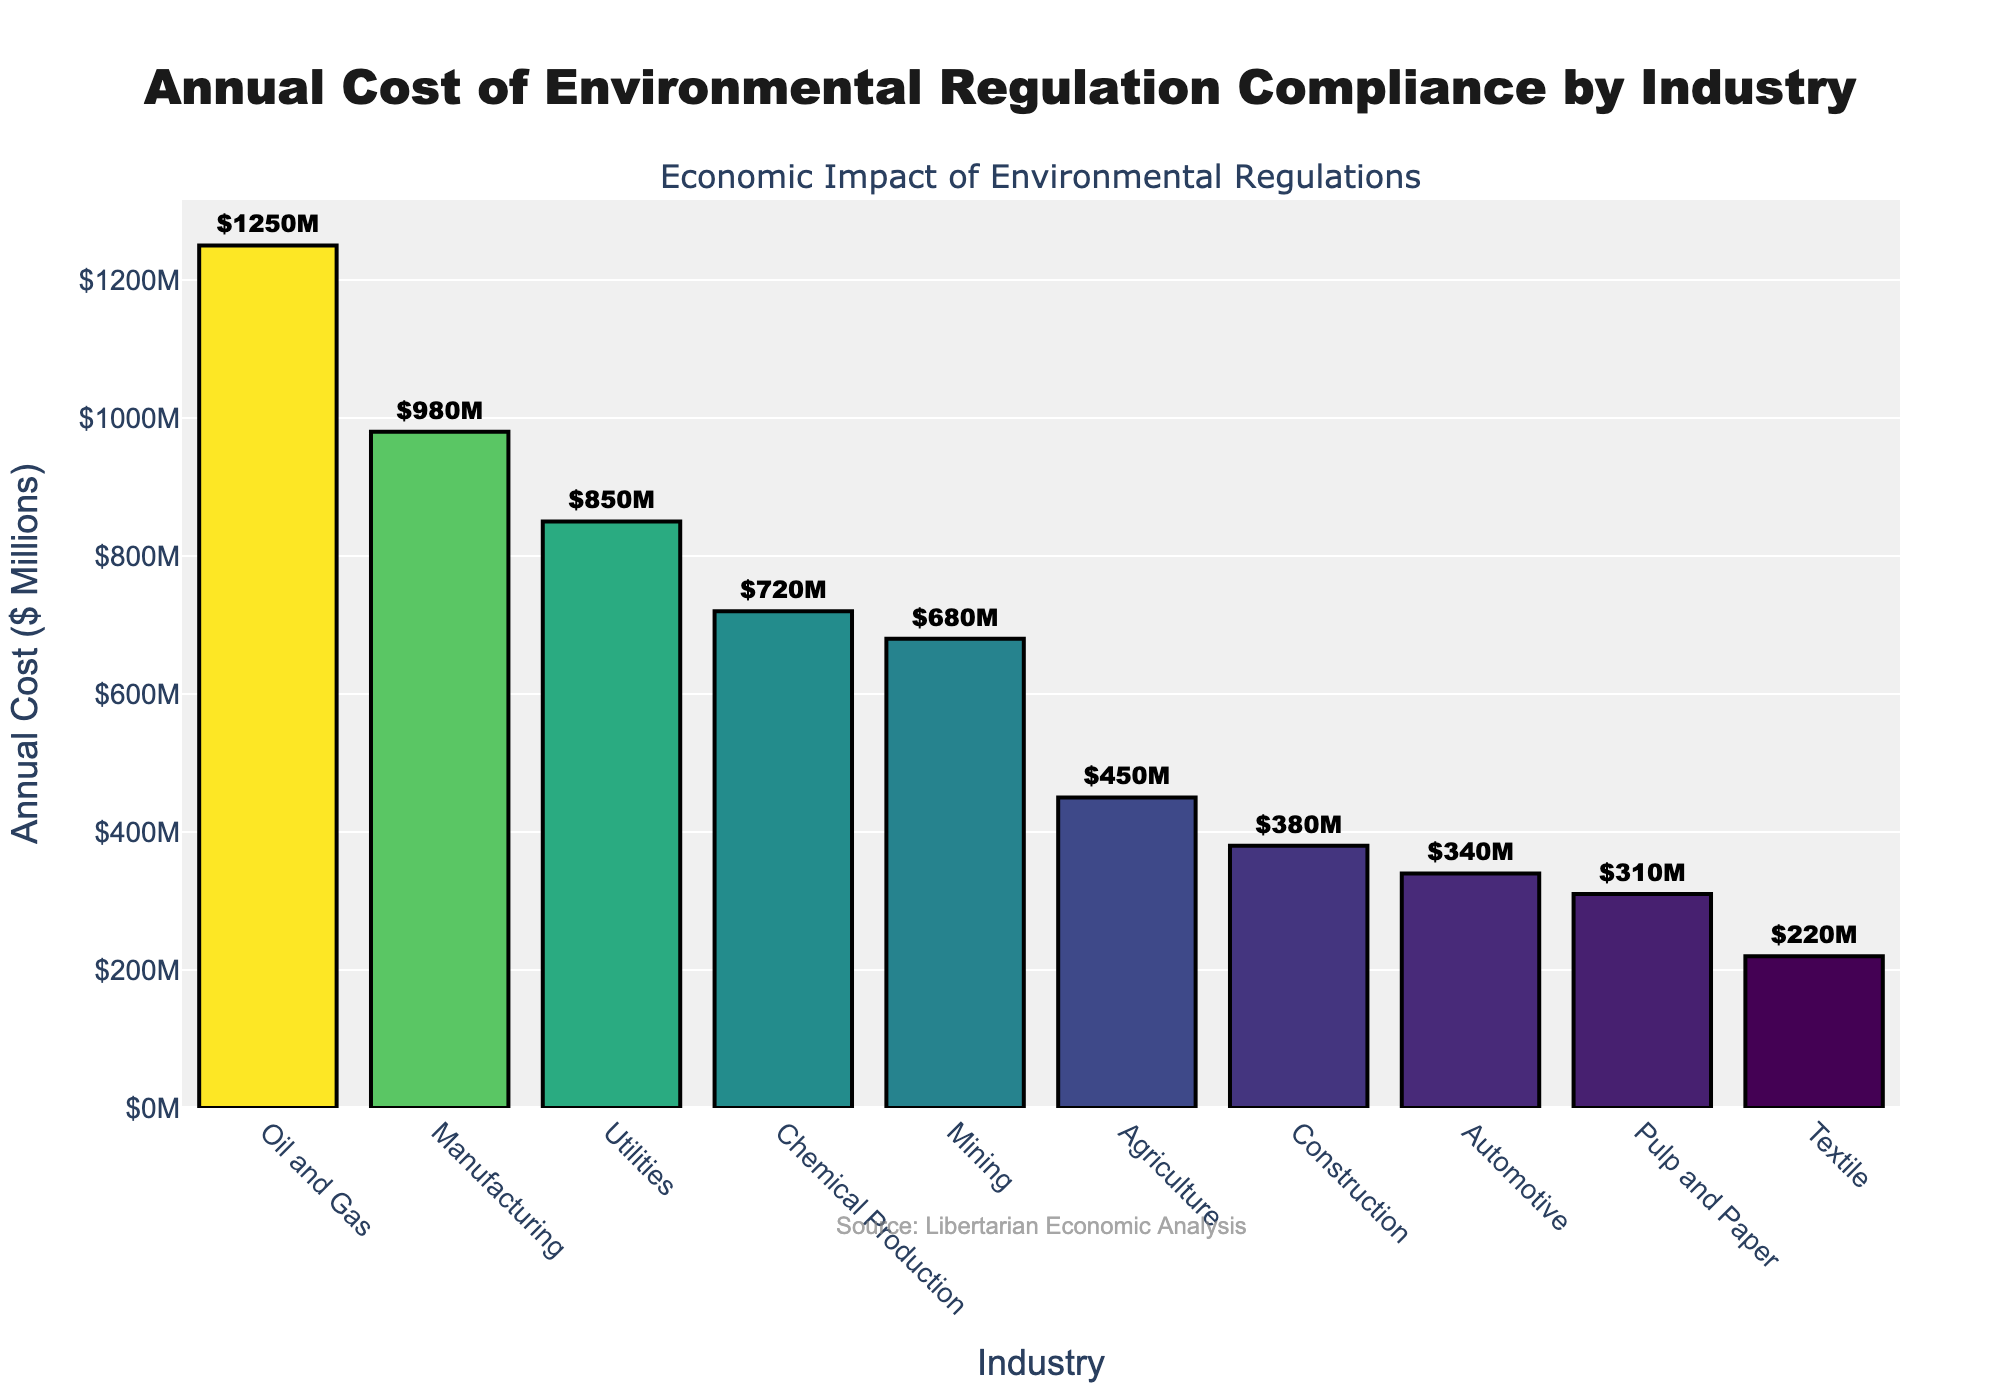What's the total annual cost of compliance across all industries? Sum up all the annual costs of compliance: 1250 + 980 + 850 + 720 + 680 + 450 + 380 + 340 + 310 + 220 = 6180 million dollars
Answer: 6180 million dollars Which industry has the highest annual cost of compliance? Look at the industry with the tallest bar in the chart, which is labeled as Oil and Gas, and its cost is $1250 million
Answer: Oil and Gas How much more does the Oil and Gas industry spend on compliance compared to the Textile industry? Subtract the annual cost of compliance of Textile ($220 million) from that of Oil and Gas ($1250 million): 1250 - 220 = 1030 million dollars
Answer: 1030 million dollars What is the average annual cost of compliance among the top three industries? Sum the costs of the top three industries: 1250 (Oil and Gas) + 980 (Manufacturing) + 850 (Utilities) = 3080, then divide by 3: 3080 ÷ 3 = 1026.67 million dollars
Answer: 1026.67 million dollars What percentage of the total cost is attributed to the Mining industry? Divide the Mining industry's cost by the total cost and multiply by 100: (680 / 6180) * 100 ≈ 11%
Answer: 11% What is the range of the annual costs of compliance across all industries? Subtract the lowest annual cost (Textile, $220 million) from the highest (Oil and Gas, $1250 million): 1250 - 220 = 1030 million dollars
Answer: 1030 million dollars Are there more industries with an annual compliance cost below $500 million or above $500 million? Count the number of industries with costs below and above $500 million. Below $500 million: 5 industries (Agriculture, Construction, Automotive, Pulp and Paper, Textile); Above $500 million: 5 industries (Oil and Gas, Manufacturing, Utilities, Chemical Production, Mining). Both are equal
Answer: Equal Which industries spend more than $700 million on compliance? Spot the bars that extend beyond $700 million: Oil and Gas, Manufacturing, Utilities, Chemical Production, Mining
Answer: Oil and Gas, Manufacturing, Utilities, Chemical Production, Mining How much less does the Automotive industry spend on compliance compared to Chemical Production? Subtract the annual cost of compliance of the Automotive industry ($340 million) from that of Chemical Production ($720 million): 720 - 340 = 380 million dollars
Answer: 380 million dollars If you were to rank industries by their annual compliance costs, what rank would Agriculture have? By ordering the industries by compliance costs, Agriculture (with $450 million) is the sixth highest
Answer: 6th 